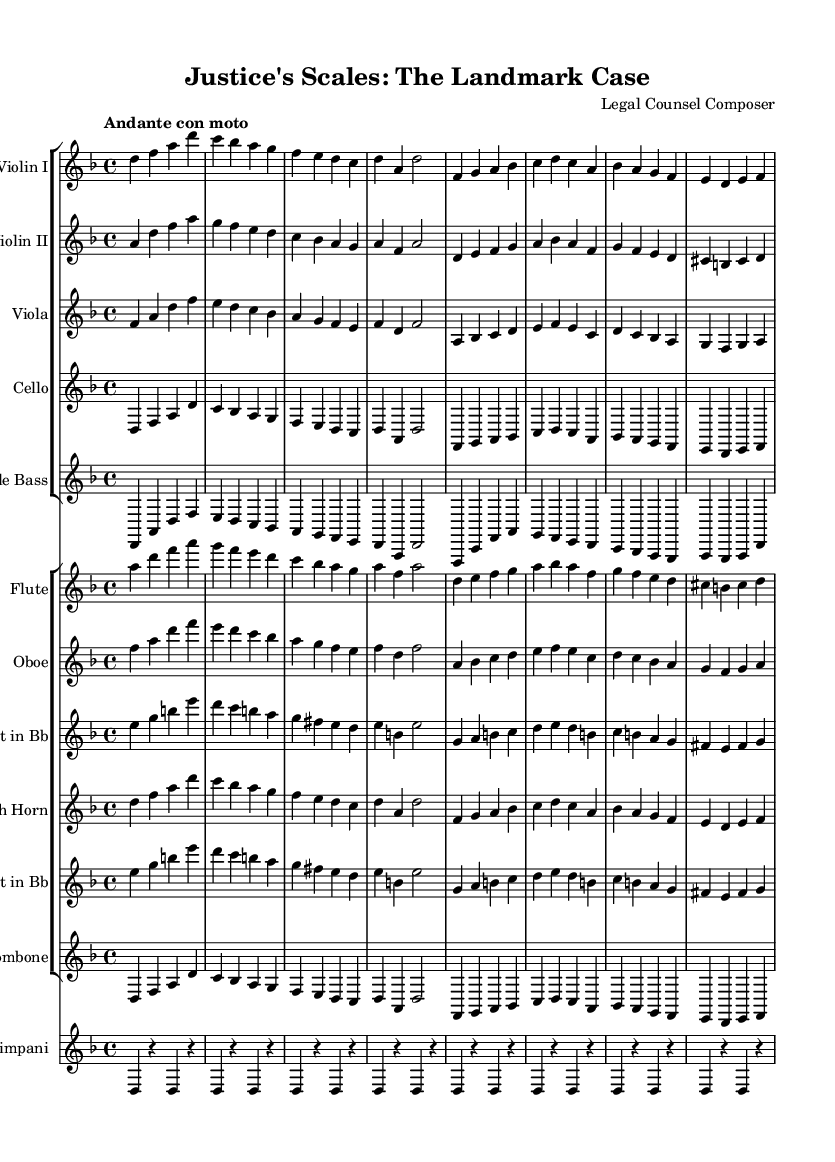What is the key signature of this music? The key signature is D minor, which has one flat (B flat). This can be identified at the beginning of the staff where the key signature is placed.
Answer: D minor What is the time signature of this music? The time signature is 4/4, indicated at the start of the music. This means there are four beats in each measure and a quarter note gets one beat.
Answer: 4/4 What is the tempo indication for this music? The tempo indication is "Andante con moto," which suggests a moderate pace that is also a bit lively. This is usually noted just above the staff at the beginning of the piece.
Answer: Andante con moto How many instruments are featured in this score? There are a total of eleven instruments available, as seen by the number of staves and separate instrument names listed in the score's structure.
Answer: Eleven Which instrument has the first melodic entrance in the score? The first melodic entrance is by the Violin I, indicated by the first staff group where the notes start at the beginning of the score.
Answer: Violin I What is the range of the violin part in this piece? The range of the Violin I part spans from D to A, which can be observed by assessing the highest and lowest notes indicated in the staff for this instrument.
Answer: D to A What does the symbol "r" in the timpani part represent? The symbol "r" stands for "rest," indicating that the timpani player should remain silent during those beats. This is evident in the repeated patterns where the player does not play notes but instead has rests.
Answer: Rest 